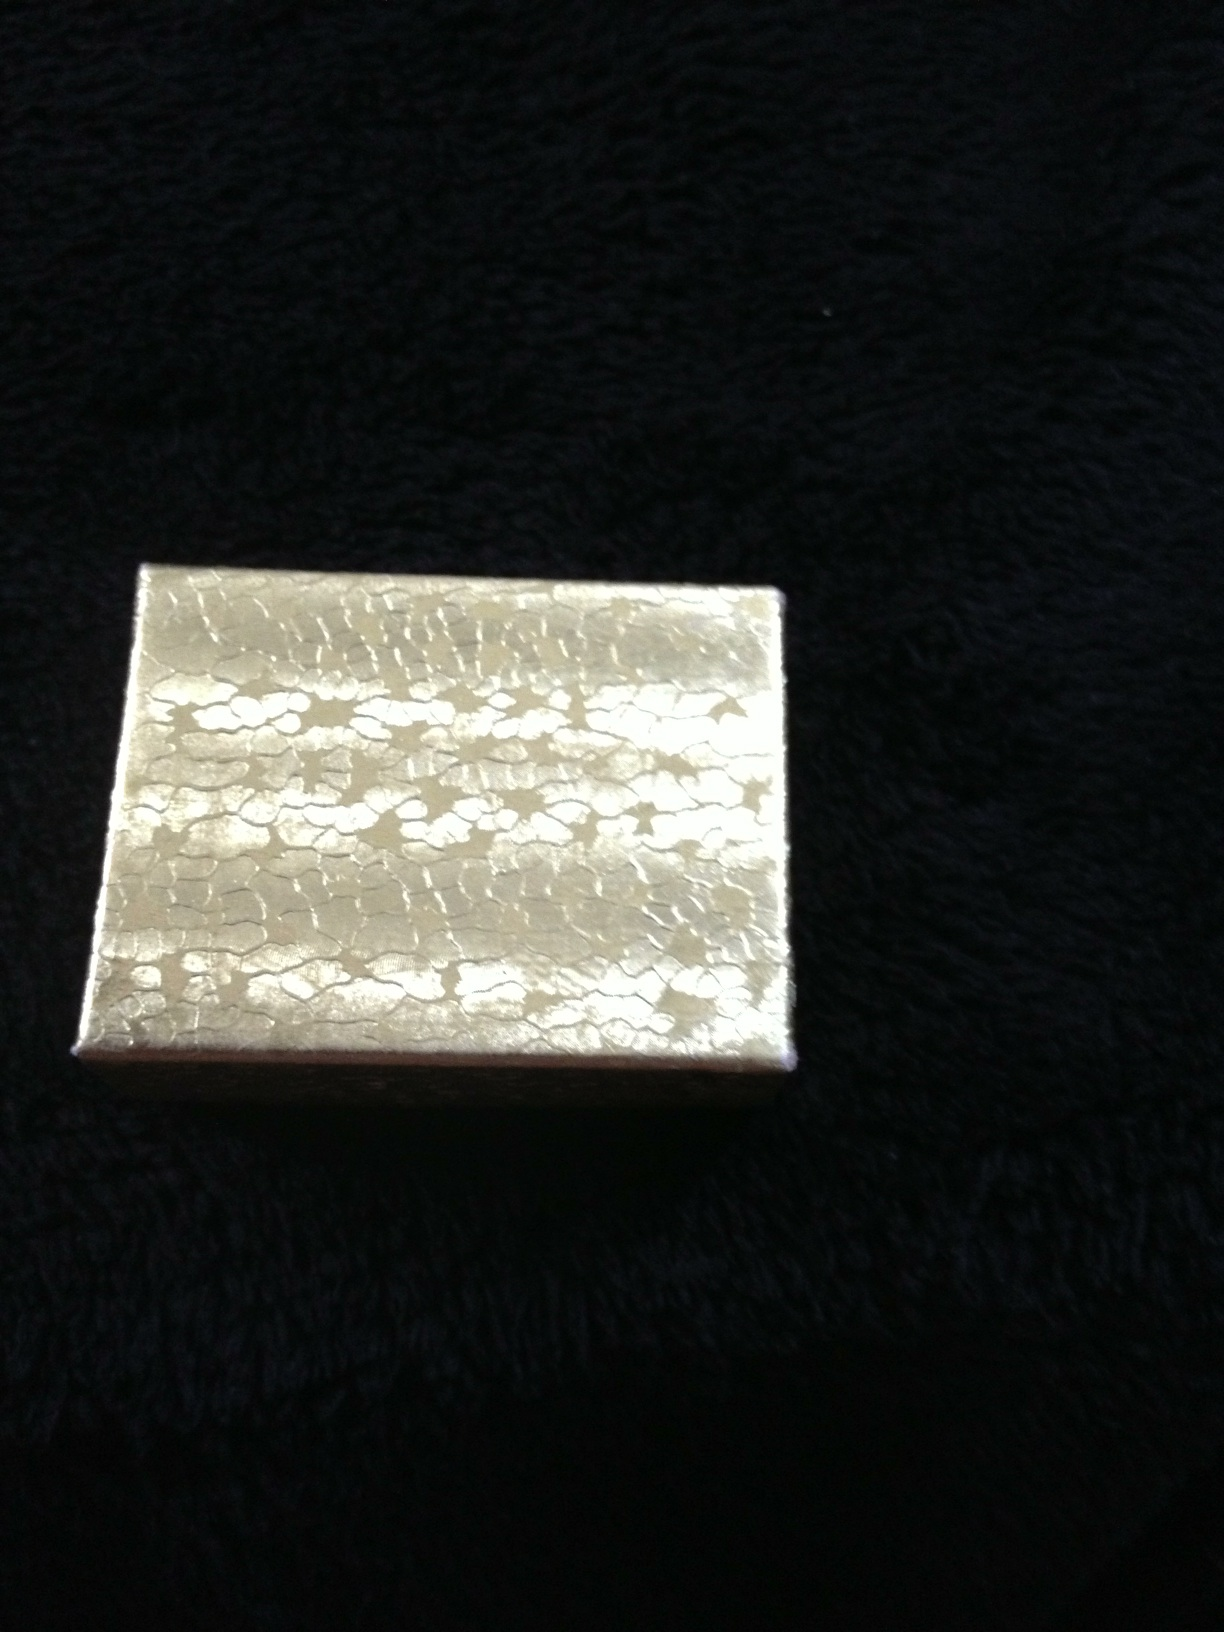What do you think this box is used for? This box seems to be quite decorative and could be used for storing small items such as jewelry, keepsakes, or other precious objects. Its elegant appearance makes it suitable for storing something special. Can you describe the texture and design of the box in detail? The box has a shimmering gold surface with a unique cracked or veined texture that appears almost like scales or mosaic. This intricate pattern adds to its decorative appeal and likely makes the box quite eye-catching in person. 